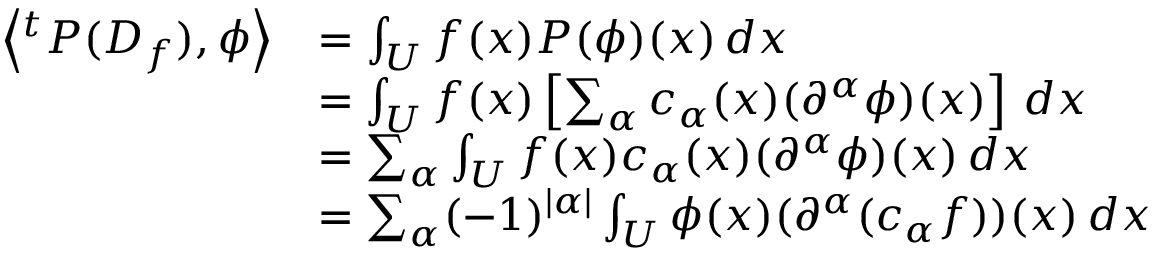<formula> <loc_0><loc_0><loc_500><loc_500>{ \begin{array} { r l } { \left \langle ^ { t } P ( D _ { f } ) , \phi \right \rangle } & { = \int _ { U } f ( x ) P ( \phi ) ( x ) \, d x } \\ & { = \int _ { U } f ( x ) \left [ \sum _ { \alpha } c _ { \alpha } ( x ) ( \partial ^ { \alpha } \phi ) ( x ) \right ] \, d x } \\ & { = \sum _ { \alpha } \int _ { U } f ( x ) c _ { \alpha } ( x ) ( \partial ^ { \alpha } \phi ) ( x ) \, d x } \\ & { = \sum _ { \alpha } ( - 1 ) ^ { | \alpha | } \int _ { U } \phi ( x ) ( \partial ^ { \alpha } ( c _ { \alpha } f ) ) ( x ) \, d x } \end{array} }</formula> 